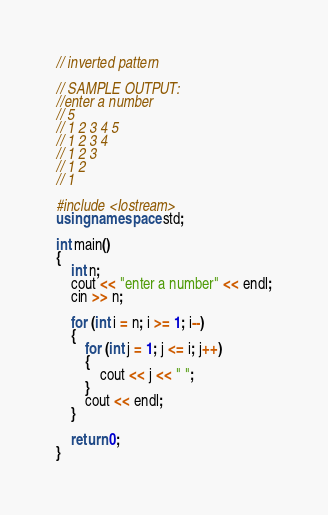<code> <loc_0><loc_0><loc_500><loc_500><_C++_>// inverted pattern

// SAMPLE OUTPUT:
//enter a number
// 5
// 1 2 3 4 5
// 1 2 3 4
// 1 2 3
// 1 2
// 1

#include <Iostream>
using namespace std;

int main()
{
    int n;
    cout << "enter a number" << endl;
    cin >> n;

    for (int i = n; i >= 1; i--)
    {
        for (int j = 1; j <= i; j++)
        {
            cout << j << " ";
        }
        cout << endl;
    }

    return 0;
}</code> 